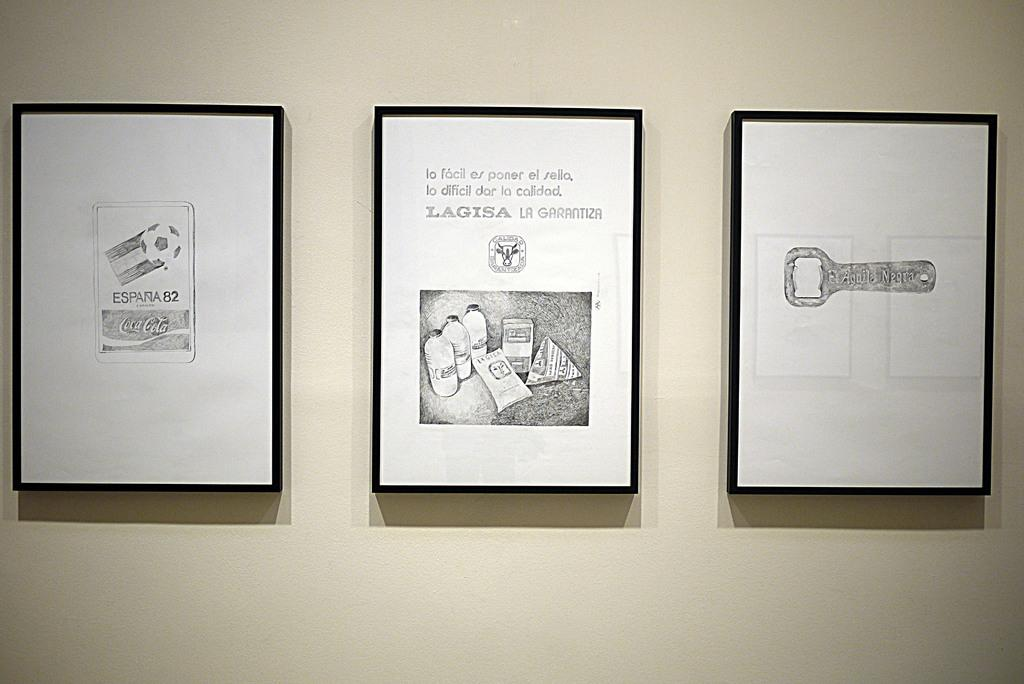<image>
Describe the image concisely. Three artworks with the subject of advertisement for Coca-cola, Lagisa and el aguila negra, respectively, are displayed on a wall. 